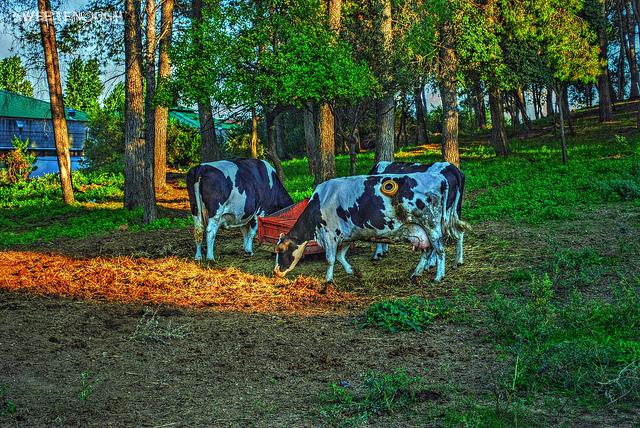What is the yellow circle on the side of the cow in the front?
Be succinct. Sun. What is the orange thing in the grass?
Concise answer only. Sunlight. Is the dog's tail above or below it's head?
Quick response, please. Below. How many cows are in the field?
Be succinct. 3. What cows are doing in the farm?
Answer briefly. Grazing. 